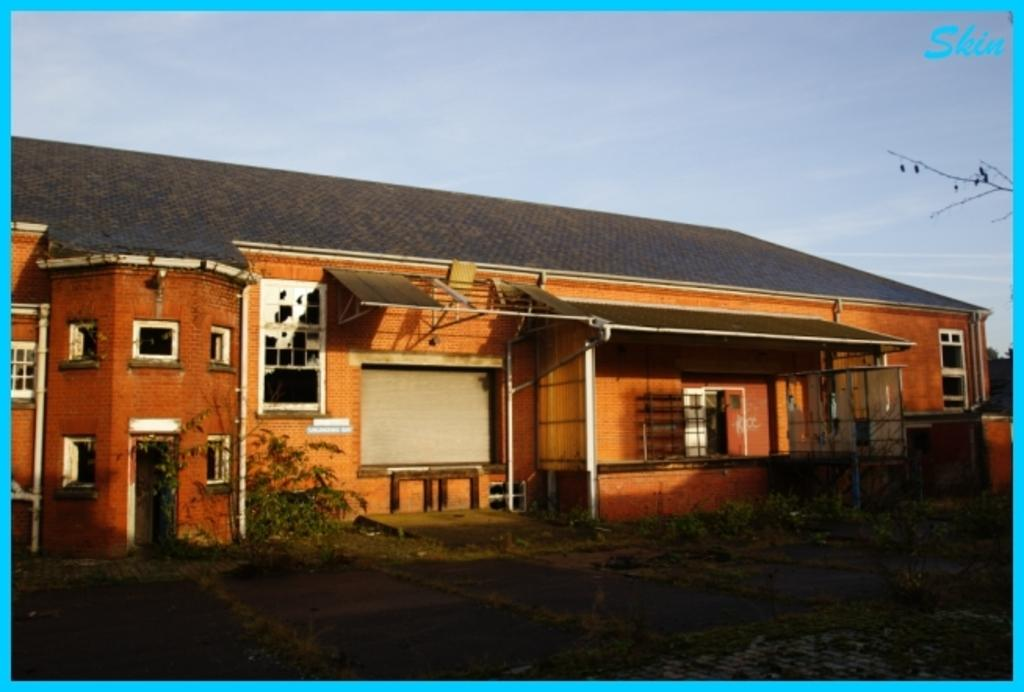What is the main subject of the image? The main subject of the image is a house. Can you describe the condition of the house? The house has broken windows. What type of environment is visible in the image? There is greenery visible in the image. How many servants are attending to the house in the image? There is no mention of servants in the image, so we cannot determine their presence or number. What type of fire can be seen in the image? There is no fire present in the image. 